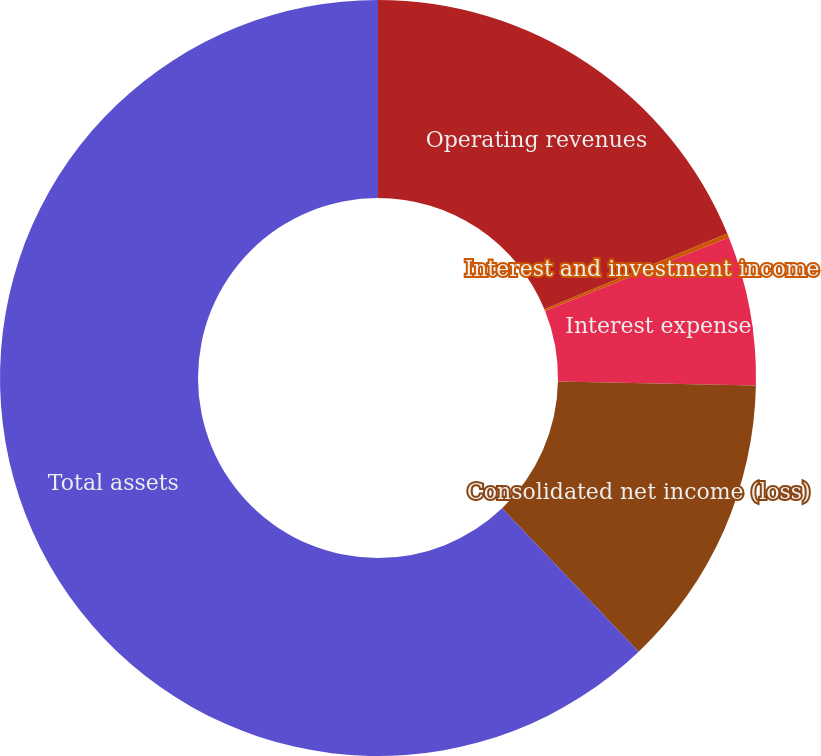Convert chart to OTSL. <chart><loc_0><loc_0><loc_500><loc_500><pie_chart><fcel>Operating revenues<fcel>Interest and investment income<fcel>Interest expense<fcel>Consolidated net income (loss)<fcel>Total assets<nl><fcel>18.76%<fcel>0.18%<fcel>6.38%<fcel>12.57%<fcel>62.11%<nl></chart> 